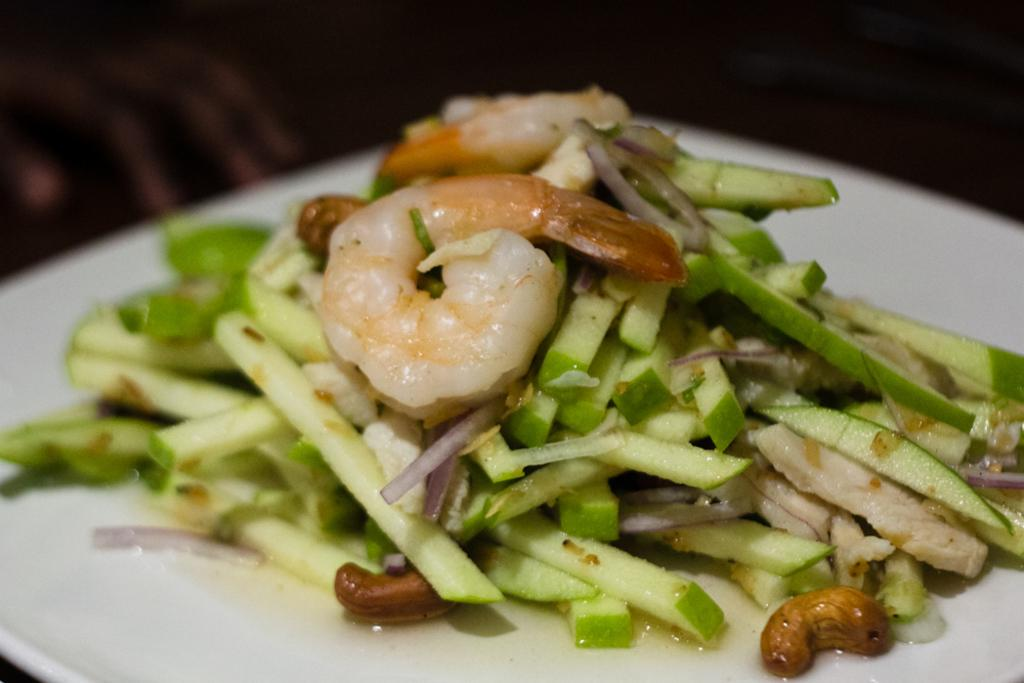What is on the plate in the image? There is food on a plate in the image. Can you describe the background of the image? The background of the image is blurry. What type of engine is being discussed in the image? There is no engine or discussion present in the image; it only features food on a plate and a blurry background. 